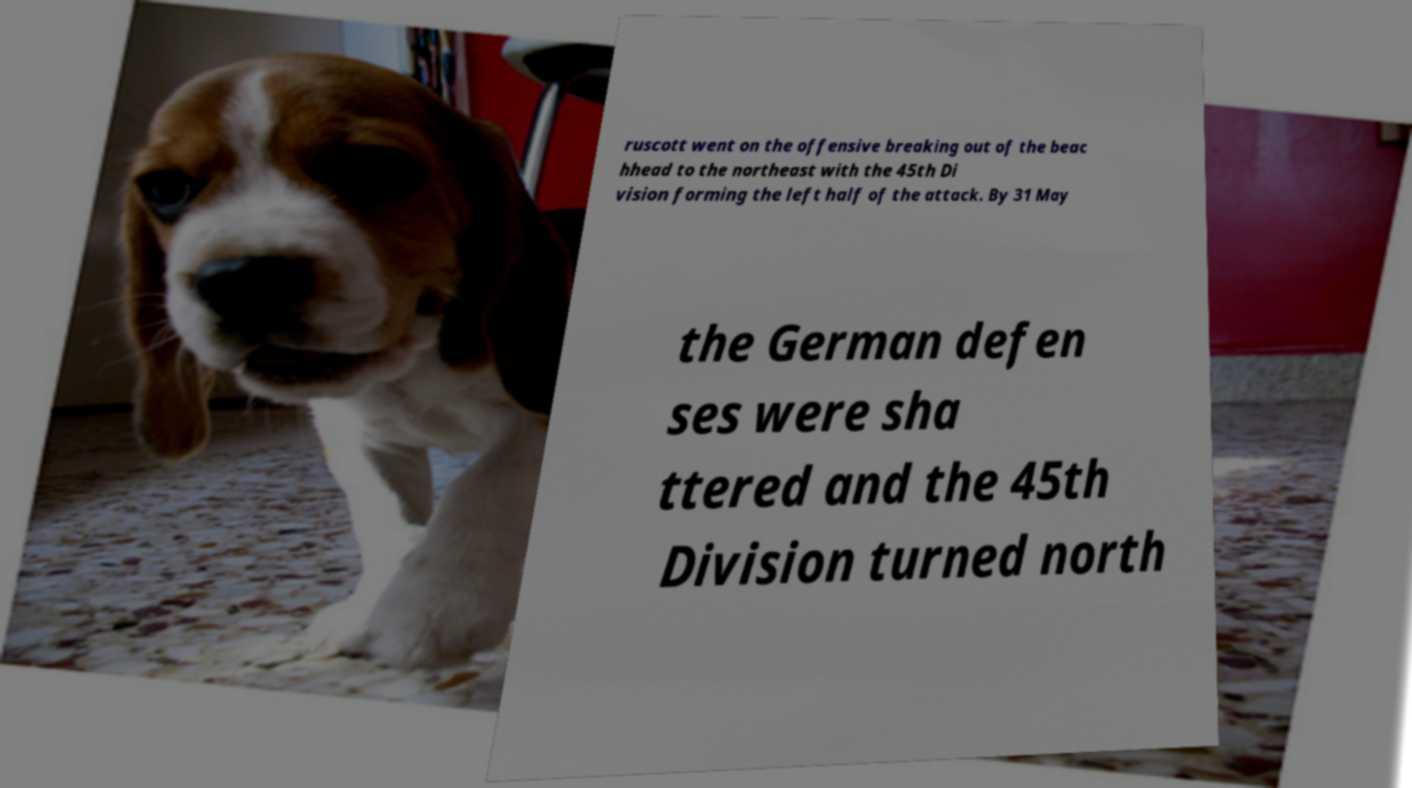Can you accurately transcribe the text from the provided image for me? ruscott went on the offensive breaking out of the beac hhead to the northeast with the 45th Di vision forming the left half of the attack. By 31 May the German defen ses were sha ttered and the 45th Division turned north 